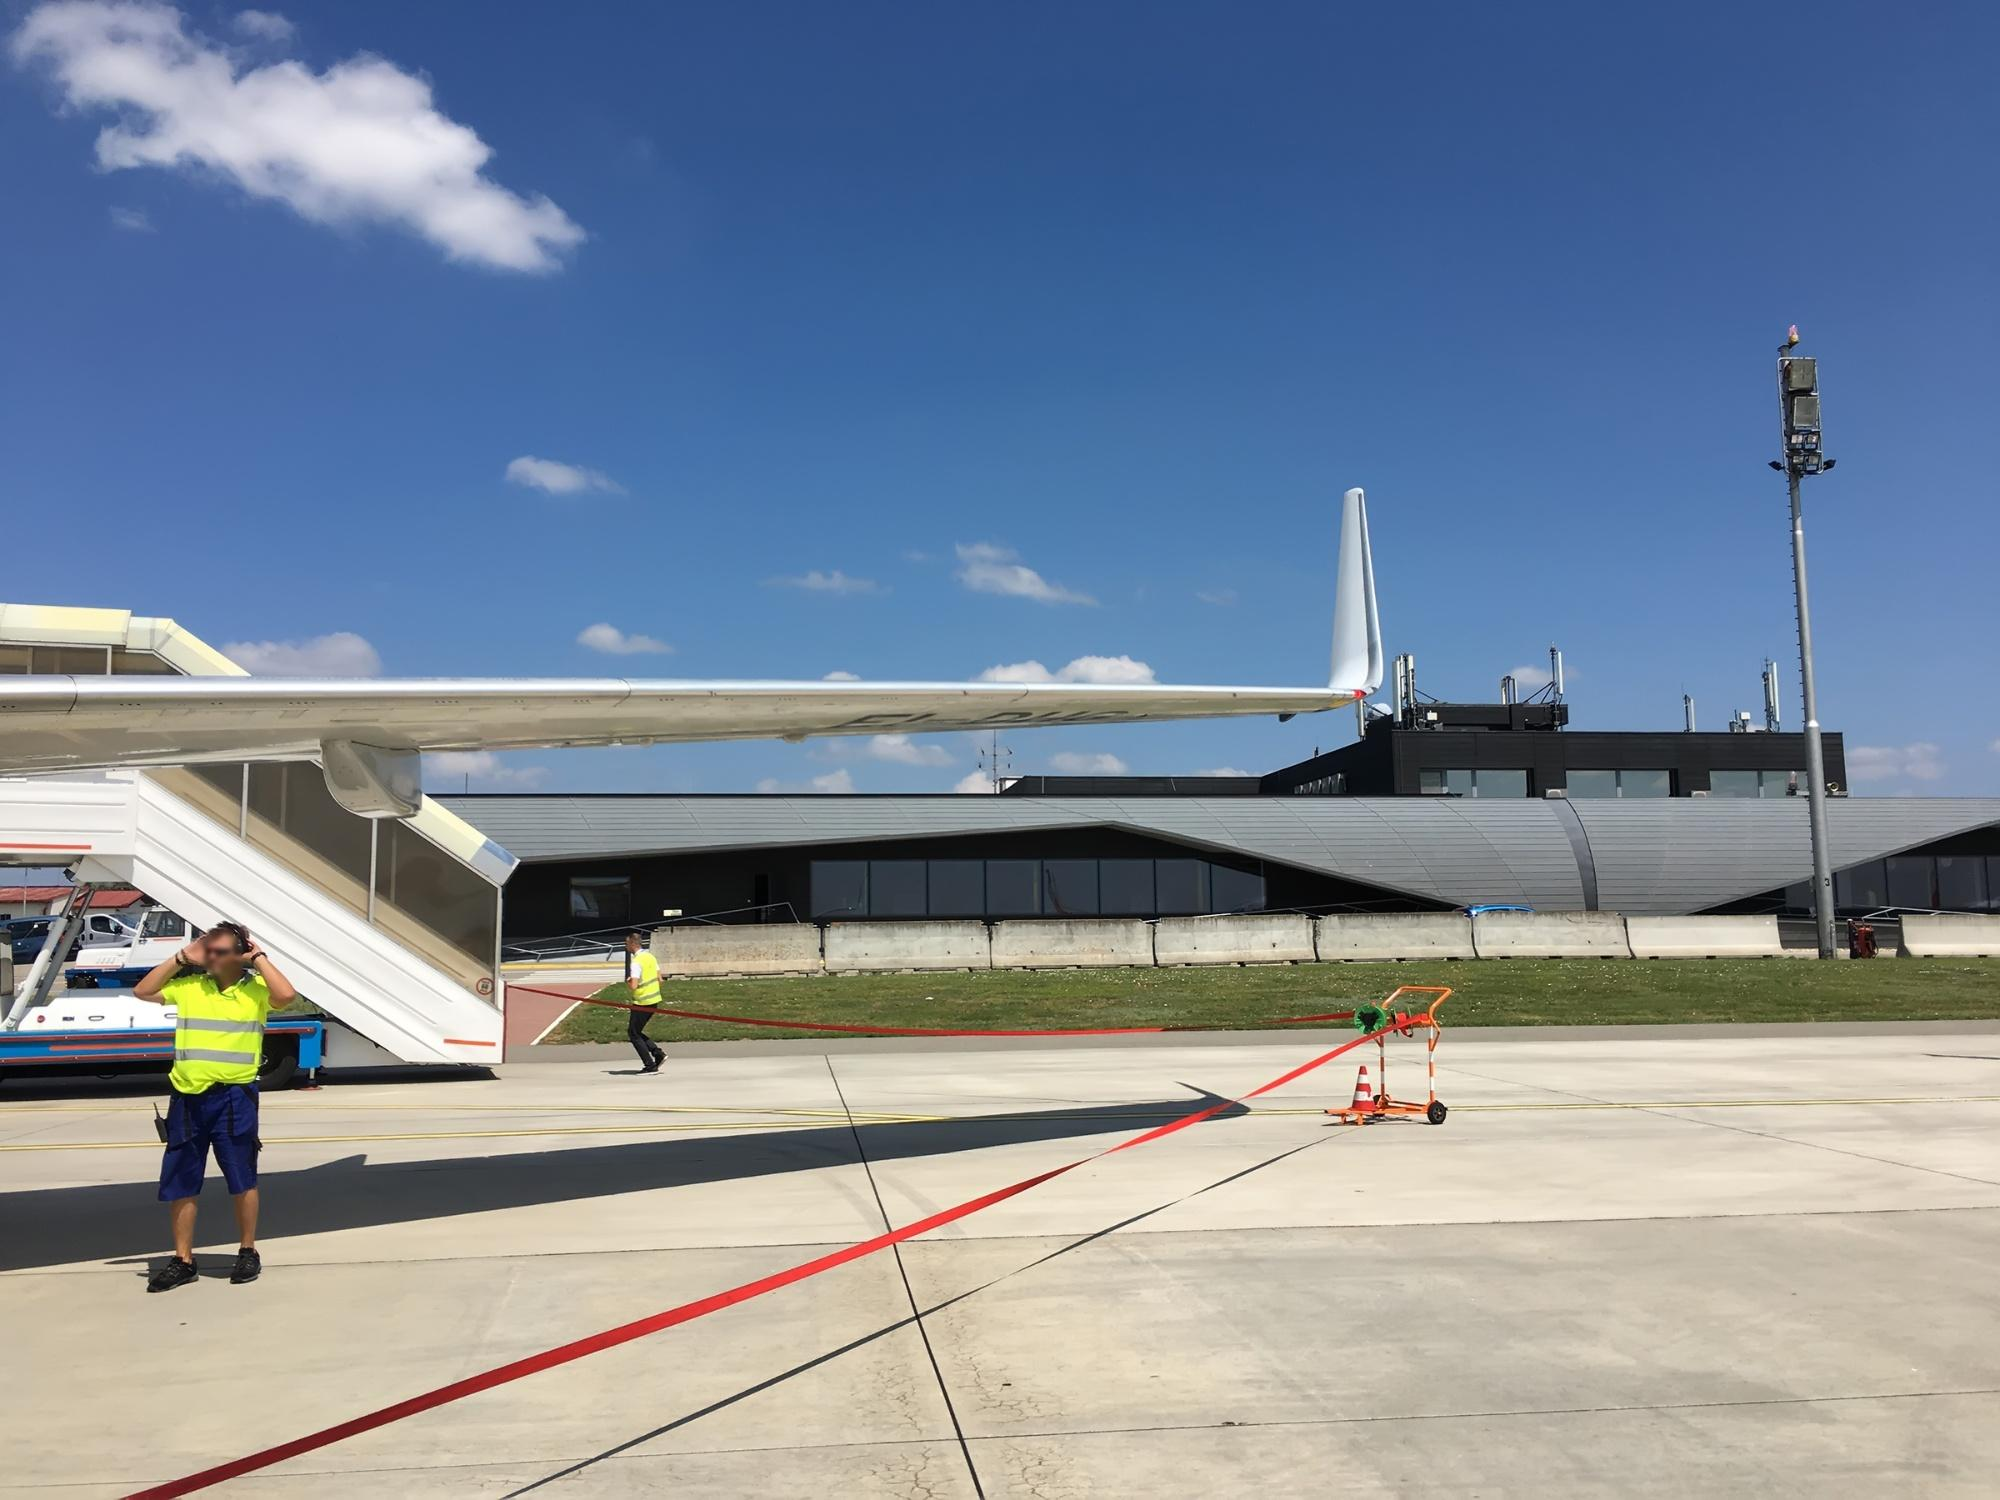What do you think is going on in this snapshot? This photograph captures a dynamic scene at an airport. Under the bright blue sky, a white airplane with a blue tail is parked close to a sleek, modern terminal building. The reflection of the sun on the tarmac highlights the hustle and bustle of the area. In the foreground, two airport workers in bright yellow vests are attending to their duties, which might include aircraft maintenance or safety checks, ensuring that everything operates efficiently. A vibrant red ladder stands nearby, likely a tool for accessing various parts of the airplane. The serenity of the sky, dotted with a few clouds, contrasts with the grounded airplane, creating a sense of anticipation for its upcoming flight. While the provided code 'sa_1568' doesn't point to a specific landmark, it might be an internal airport reference. Overall, this image beautifully captures the intersection of human effort and technological marvels in the world of aviation. 